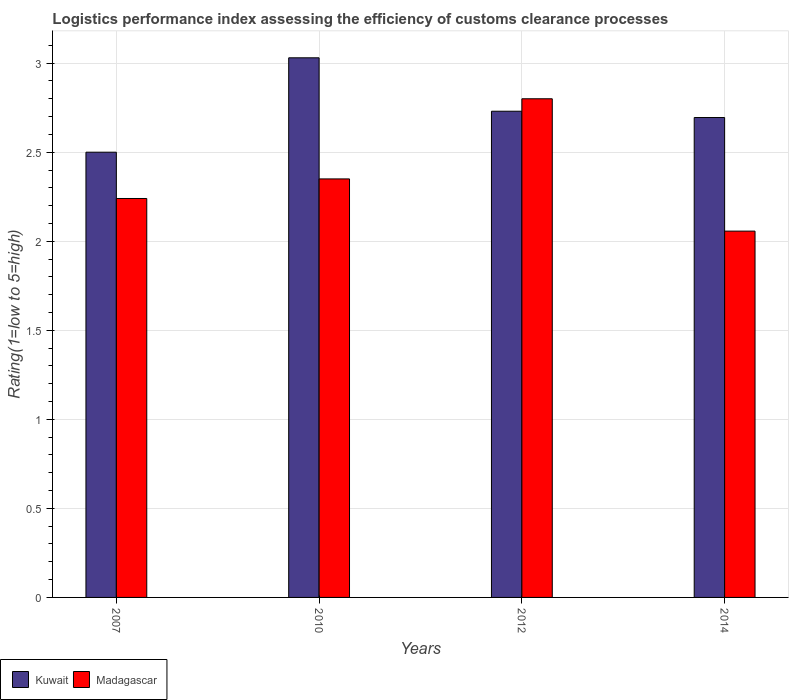How many different coloured bars are there?
Provide a succinct answer. 2. How many groups of bars are there?
Ensure brevity in your answer.  4. Are the number of bars per tick equal to the number of legend labels?
Your answer should be very brief. Yes. Are the number of bars on each tick of the X-axis equal?
Offer a terse response. Yes. How many bars are there on the 1st tick from the right?
Offer a terse response. 2. What is the label of the 1st group of bars from the left?
Your response must be concise. 2007. Across all years, what is the maximum Logistic performance index in Kuwait?
Ensure brevity in your answer.  3.03. Across all years, what is the minimum Logistic performance index in Madagascar?
Offer a very short reply. 2.06. In which year was the Logistic performance index in Madagascar maximum?
Give a very brief answer. 2012. In which year was the Logistic performance index in Madagascar minimum?
Your response must be concise. 2014. What is the total Logistic performance index in Madagascar in the graph?
Your answer should be compact. 9.45. What is the difference between the Logistic performance index in Kuwait in 2007 and that in 2010?
Your answer should be very brief. -0.53. What is the difference between the Logistic performance index in Kuwait in 2010 and the Logistic performance index in Madagascar in 2014?
Make the answer very short. 0.97. What is the average Logistic performance index in Madagascar per year?
Your response must be concise. 2.36. In the year 2010, what is the difference between the Logistic performance index in Madagascar and Logistic performance index in Kuwait?
Keep it short and to the point. -0.68. What is the ratio of the Logistic performance index in Kuwait in 2007 to that in 2010?
Make the answer very short. 0.83. What is the difference between the highest and the second highest Logistic performance index in Madagascar?
Make the answer very short. 0.45. What is the difference between the highest and the lowest Logistic performance index in Madagascar?
Your answer should be very brief. 0.74. In how many years, is the Logistic performance index in Madagascar greater than the average Logistic performance index in Madagascar taken over all years?
Give a very brief answer. 1. Is the sum of the Logistic performance index in Kuwait in 2007 and 2012 greater than the maximum Logistic performance index in Madagascar across all years?
Provide a short and direct response. Yes. What does the 2nd bar from the left in 2014 represents?
Offer a very short reply. Madagascar. What does the 1st bar from the right in 2012 represents?
Ensure brevity in your answer.  Madagascar. Where does the legend appear in the graph?
Ensure brevity in your answer.  Bottom left. How many legend labels are there?
Offer a very short reply. 2. How are the legend labels stacked?
Offer a terse response. Horizontal. What is the title of the graph?
Provide a succinct answer. Logistics performance index assessing the efficiency of customs clearance processes. Does "Panama" appear as one of the legend labels in the graph?
Your answer should be compact. No. What is the label or title of the Y-axis?
Ensure brevity in your answer.  Rating(1=low to 5=high). What is the Rating(1=low to 5=high) in Kuwait in 2007?
Make the answer very short. 2.5. What is the Rating(1=low to 5=high) of Madagascar in 2007?
Your answer should be very brief. 2.24. What is the Rating(1=low to 5=high) in Kuwait in 2010?
Provide a short and direct response. 3.03. What is the Rating(1=low to 5=high) of Madagascar in 2010?
Offer a very short reply. 2.35. What is the Rating(1=low to 5=high) of Kuwait in 2012?
Keep it short and to the point. 2.73. What is the Rating(1=low to 5=high) in Madagascar in 2012?
Your response must be concise. 2.8. What is the Rating(1=low to 5=high) in Kuwait in 2014?
Your response must be concise. 2.69. What is the Rating(1=low to 5=high) in Madagascar in 2014?
Offer a very short reply. 2.06. Across all years, what is the maximum Rating(1=low to 5=high) of Kuwait?
Offer a very short reply. 3.03. Across all years, what is the maximum Rating(1=low to 5=high) in Madagascar?
Offer a terse response. 2.8. Across all years, what is the minimum Rating(1=low to 5=high) in Kuwait?
Keep it short and to the point. 2.5. Across all years, what is the minimum Rating(1=low to 5=high) of Madagascar?
Provide a succinct answer. 2.06. What is the total Rating(1=low to 5=high) of Kuwait in the graph?
Make the answer very short. 10.95. What is the total Rating(1=low to 5=high) in Madagascar in the graph?
Your answer should be compact. 9.45. What is the difference between the Rating(1=low to 5=high) of Kuwait in 2007 and that in 2010?
Offer a very short reply. -0.53. What is the difference between the Rating(1=low to 5=high) in Madagascar in 2007 and that in 2010?
Keep it short and to the point. -0.11. What is the difference between the Rating(1=low to 5=high) of Kuwait in 2007 and that in 2012?
Give a very brief answer. -0.23. What is the difference between the Rating(1=low to 5=high) in Madagascar in 2007 and that in 2012?
Your response must be concise. -0.56. What is the difference between the Rating(1=low to 5=high) of Kuwait in 2007 and that in 2014?
Ensure brevity in your answer.  -0.19. What is the difference between the Rating(1=low to 5=high) of Madagascar in 2007 and that in 2014?
Provide a short and direct response. 0.18. What is the difference between the Rating(1=low to 5=high) of Kuwait in 2010 and that in 2012?
Your answer should be compact. 0.3. What is the difference between the Rating(1=low to 5=high) in Madagascar in 2010 and that in 2012?
Your answer should be very brief. -0.45. What is the difference between the Rating(1=low to 5=high) of Kuwait in 2010 and that in 2014?
Provide a succinct answer. 0.34. What is the difference between the Rating(1=low to 5=high) of Madagascar in 2010 and that in 2014?
Ensure brevity in your answer.  0.29. What is the difference between the Rating(1=low to 5=high) in Kuwait in 2012 and that in 2014?
Offer a terse response. 0.04. What is the difference between the Rating(1=low to 5=high) in Madagascar in 2012 and that in 2014?
Your answer should be very brief. 0.74. What is the difference between the Rating(1=low to 5=high) of Kuwait in 2007 and the Rating(1=low to 5=high) of Madagascar in 2010?
Keep it short and to the point. 0.15. What is the difference between the Rating(1=low to 5=high) of Kuwait in 2007 and the Rating(1=low to 5=high) of Madagascar in 2012?
Provide a succinct answer. -0.3. What is the difference between the Rating(1=low to 5=high) in Kuwait in 2007 and the Rating(1=low to 5=high) in Madagascar in 2014?
Your answer should be very brief. 0.44. What is the difference between the Rating(1=low to 5=high) in Kuwait in 2010 and the Rating(1=low to 5=high) in Madagascar in 2012?
Your answer should be very brief. 0.23. What is the difference between the Rating(1=low to 5=high) of Kuwait in 2010 and the Rating(1=low to 5=high) of Madagascar in 2014?
Make the answer very short. 0.97. What is the difference between the Rating(1=low to 5=high) of Kuwait in 2012 and the Rating(1=low to 5=high) of Madagascar in 2014?
Make the answer very short. 0.67. What is the average Rating(1=low to 5=high) in Kuwait per year?
Your answer should be compact. 2.74. What is the average Rating(1=low to 5=high) in Madagascar per year?
Your answer should be compact. 2.36. In the year 2007, what is the difference between the Rating(1=low to 5=high) of Kuwait and Rating(1=low to 5=high) of Madagascar?
Offer a terse response. 0.26. In the year 2010, what is the difference between the Rating(1=low to 5=high) of Kuwait and Rating(1=low to 5=high) of Madagascar?
Give a very brief answer. 0.68. In the year 2012, what is the difference between the Rating(1=low to 5=high) in Kuwait and Rating(1=low to 5=high) in Madagascar?
Provide a short and direct response. -0.07. In the year 2014, what is the difference between the Rating(1=low to 5=high) of Kuwait and Rating(1=low to 5=high) of Madagascar?
Ensure brevity in your answer.  0.64. What is the ratio of the Rating(1=low to 5=high) in Kuwait in 2007 to that in 2010?
Provide a short and direct response. 0.83. What is the ratio of the Rating(1=low to 5=high) of Madagascar in 2007 to that in 2010?
Provide a succinct answer. 0.95. What is the ratio of the Rating(1=low to 5=high) in Kuwait in 2007 to that in 2012?
Give a very brief answer. 0.92. What is the ratio of the Rating(1=low to 5=high) of Kuwait in 2007 to that in 2014?
Offer a very short reply. 0.93. What is the ratio of the Rating(1=low to 5=high) in Madagascar in 2007 to that in 2014?
Give a very brief answer. 1.09. What is the ratio of the Rating(1=low to 5=high) in Kuwait in 2010 to that in 2012?
Offer a terse response. 1.11. What is the ratio of the Rating(1=low to 5=high) of Madagascar in 2010 to that in 2012?
Your answer should be very brief. 0.84. What is the ratio of the Rating(1=low to 5=high) in Kuwait in 2010 to that in 2014?
Your response must be concise. 1.12. What is the ratio of the Rating(1=low to 5=high) of Madagascar in 2010 to that in 2014?
Keep it short and to the point. 1.14. What is the ratio of the Rating(1=low to 5=high) in Kuwait in 2012 to that in 2014?
Your response must be concise. 1.01. What is the ratio of the Rating(1=low to 5=high) in Madagascar in 2012 to that in 2014?
Keep it short and to the point. 1.36. What is the difference between the highest and the second highest Rating(1=low to 5=high) in Madagascar?
Offer a very short reply. 0.45. What is the difference between the highest and the lowest Rating(1=low to 5=high) of Kuwait?
Make the answer very short. 0.53. What is the difference between the highest and the lowest Rating(1=low to 5=high) of Madagascar?
Your answer should be compact. 0.74. 